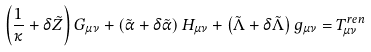Convert formula to latex. <formula><loc_0><loc_0><loc_500><loc_500>\left ( \frac { 1 } { \kappa } + \delta \tilde { Z } \right ) G _ { \mu \nu } + \left ( \tilde { \alpha } + \delta \tilde { \alpha } \right ) H _ { \mu \nu } + \left ( \tilde { \Lambda } + \delta \tilde { \Lambda } \right ) g _ { \mu \nu } = T _ { \mu \nu } ^ { r e n }</formula> 